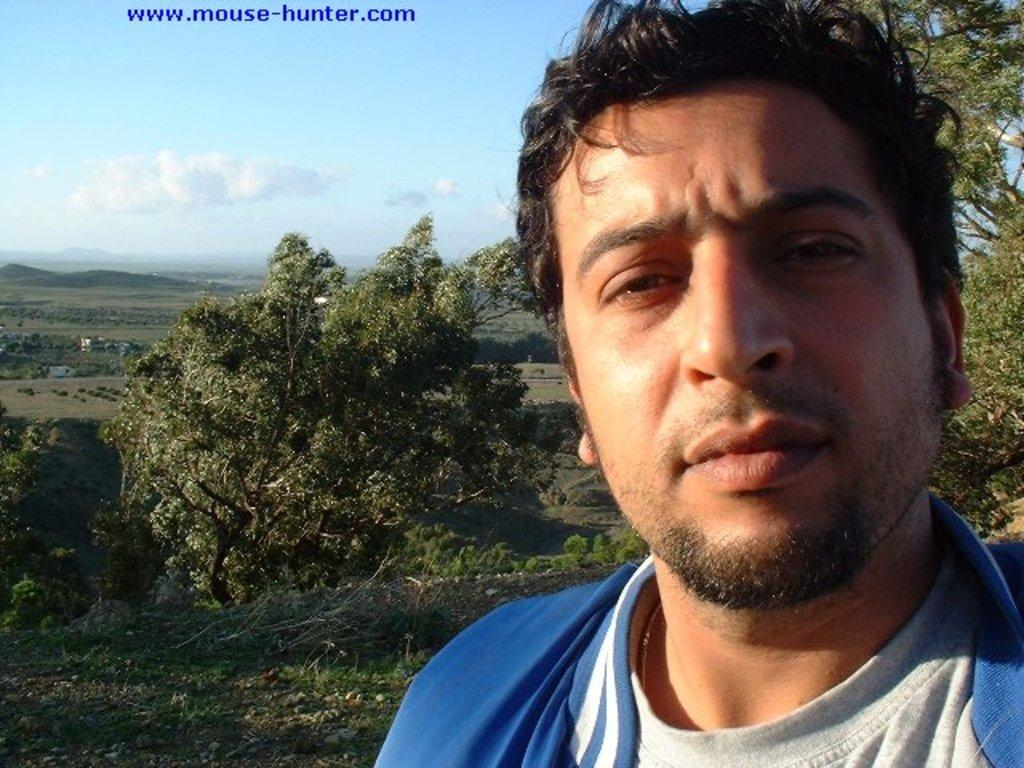Who is present in the image? There is a man in the image. What is located behind the man? There are plants behind the man. What can be seen in the background of the image? Hills and clouds are visible in the background of the image. Is there any text or marking on the image? Yes, there is a watermark on the top of the image. What story does the man tell the plants in the image? There is no indication in the image that the man is telling a story to the plants, as there is no dialogue or interaction between them. 